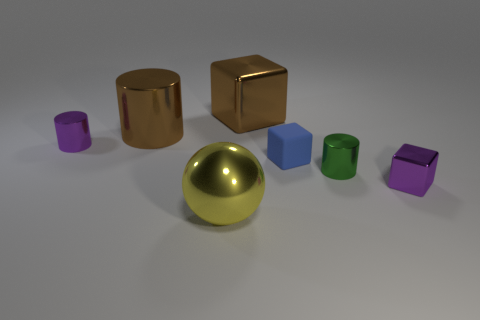The large metallic object that is in front of the tiny green cylinder has what shape?
Give a very brief answer. Sphere. Do the big yellow metal object and the rubber object have the same shape?
Your response must be concise. No. What size is the purple thing that is the same shape as the small green object?
Give a very brief answer. Small. There is a cylinder that is left of the brown cylinder; does it have the same size as the tiny blue cube?
Make the answer very short. Yes. How big is the object that is both on the right side of the brown block and to the left of the green thing?
Give a very brief answer. Small. What material is the thing that is the same color as the small metal cube?
Provide a short and direct response. Metal. What number of metallic cylinders have the same color as the small metallic block?
Offer a very short reply. 1. Are there an equal number of tiny purple shiny cylinders in front of the small blue block and big blue cylinders?
Ensure brevity in your answer.  Yes. What is the color of the tiny rubber thing?
Offer a very short reply. Blue. There is a brown cylinder that is made of the same material as the green thing; what size is it?
Ensure brevity in your answer.  Large. 